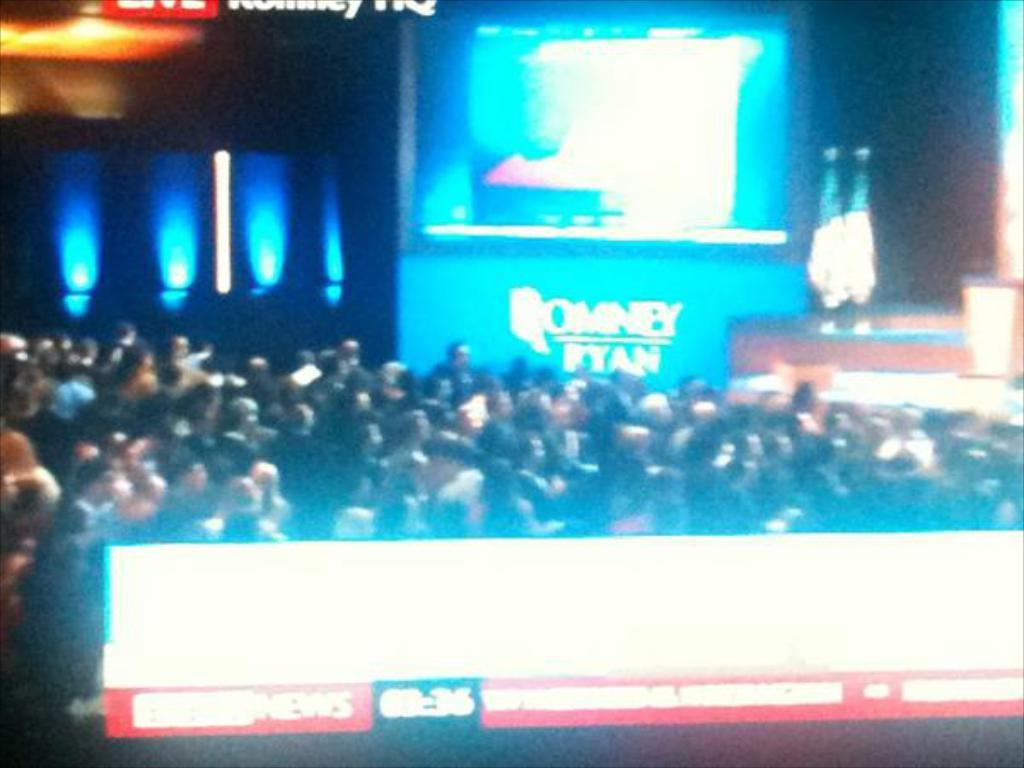How many people are in the image? There is a group of people in the image, but the exact number cannot be determined from the provided facts. What can be seen on the screens in the image? The provided facts do not specify what is displayed on the screens. What type of lights are present in the image? The provided facts do not specify the type of lights in the image. Can you describe the objects in the image? The provided facts do not specify the nature or appearance of the objects in the image. How many houses can be seen in the image? There is no mention of houses in the provided facts, so we cannot determine their presence or number in the image. What type of sponge is being used by the people in the image? There is no mention of a sponge in the provided facts, so we cannot determine its presence or use in the image. 